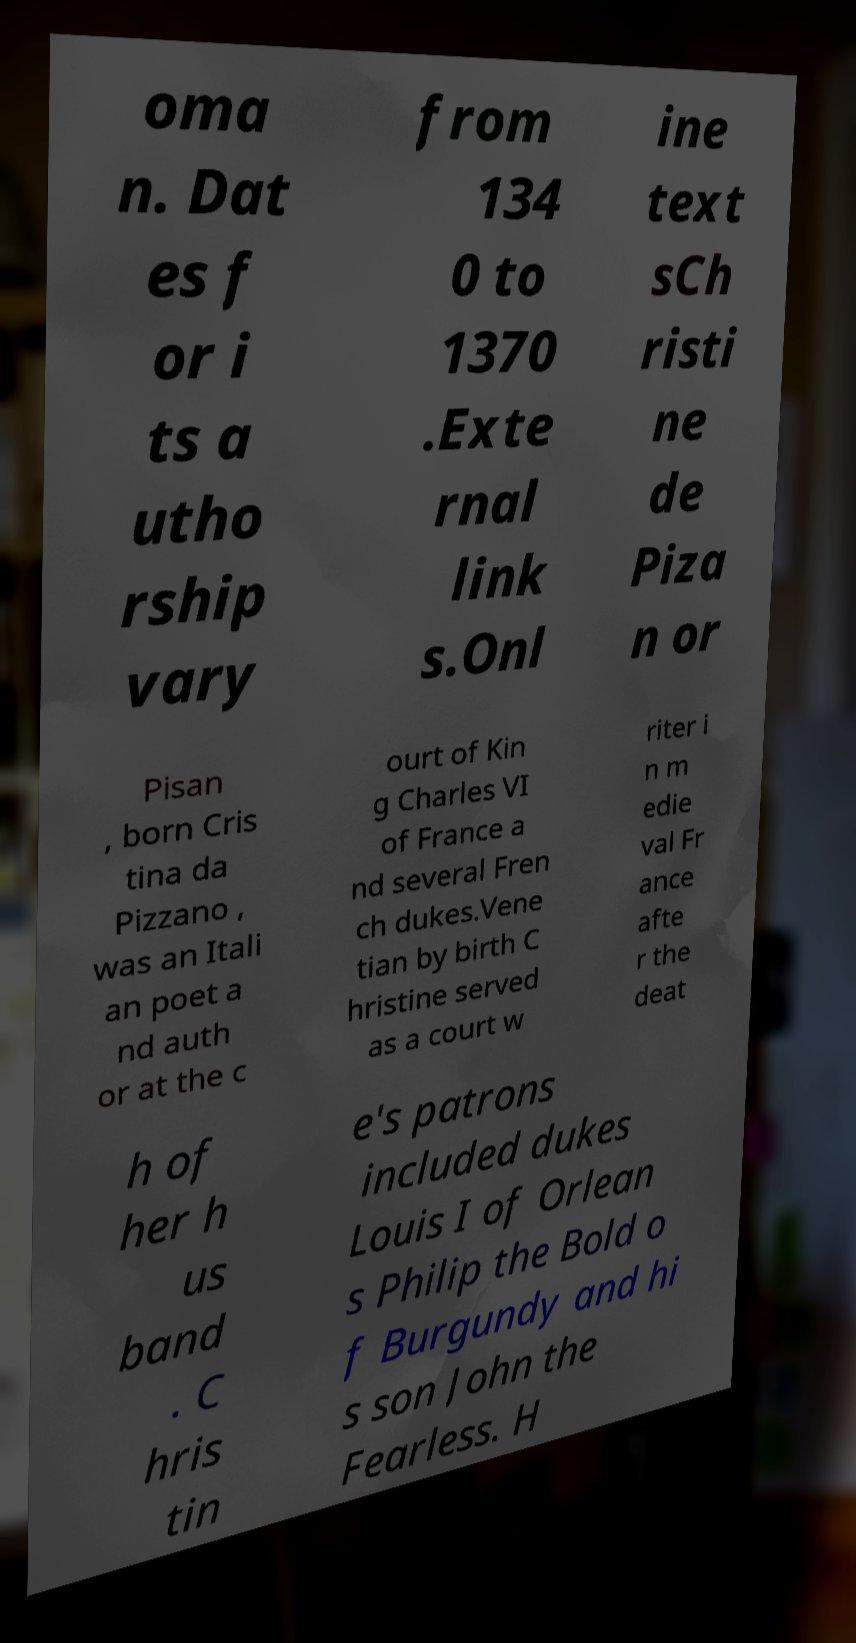What messages or text are displayed in this image? I need them in a readable, typed format. oma n. Dat es f or i ts a utho rship vary from 134 0 to 1370 .Exte rnal link s.Onl ine text sCh risti ne de Piza n or Pisan , born Cris tina da Pizzano , was an Itali an poet a nd auth or at the c ourt of Kin g Charles VI of France a nd several Fren ch dukes.Vene tian by birth C hristine served as a court w riter i n m edie val Fr ance afte r the deat h of her h us band . C hris tin e's patrons included dukes Louis I of Orlean s Philip the Bold o f Burgundy and hi s son John the Fearless. H 